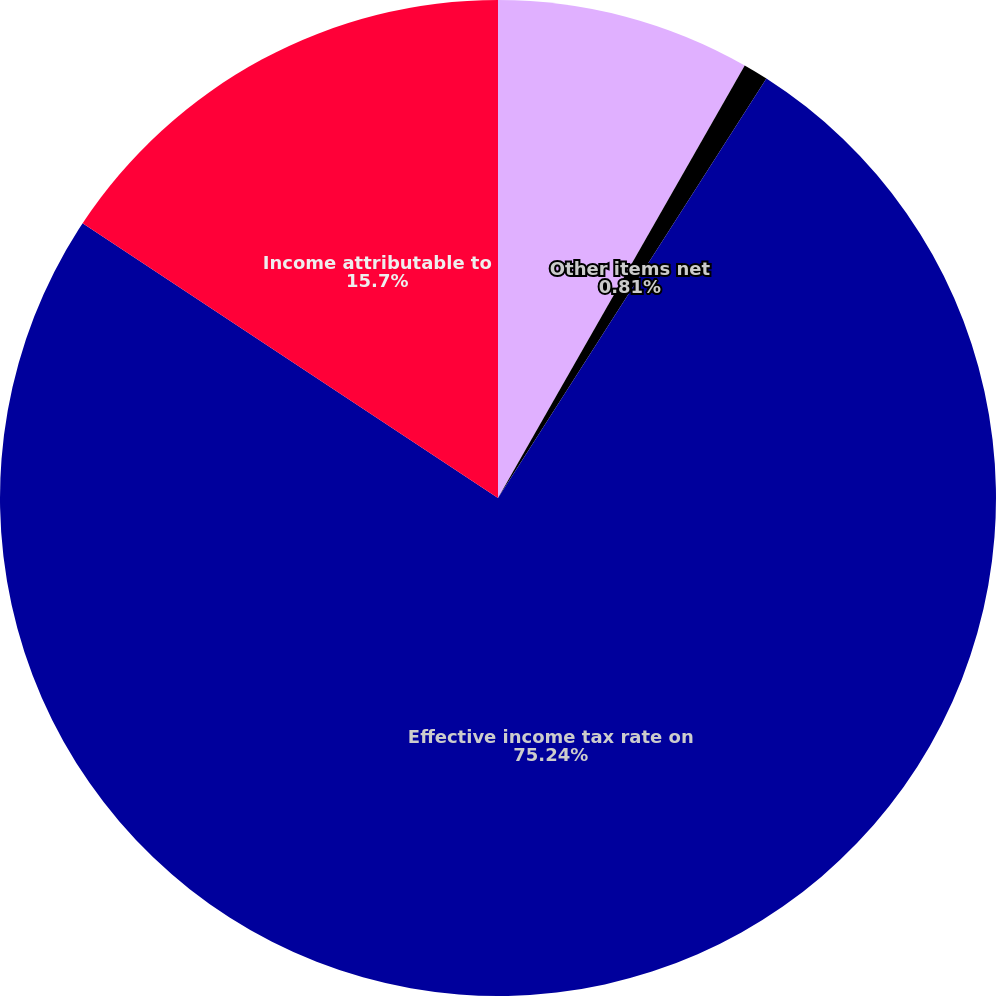Convert chart to OTSL. <chart><loc_0><loc_0><loc_500><loc_500><pie_chart><fcel>State income taxes net of<fcel>Other items net<fcel>Effective income tax rate on<fcel>Income attributable to<nl><fcel>8.25%<fcel>0.81%<fcel>75.24%<fcel>15.7%<nl></chart> 